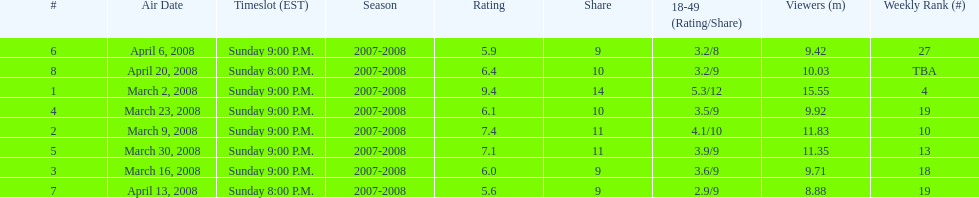Which air date had the least viewers? April 13, 2008. 